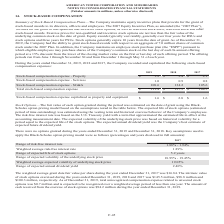According to American Tower Corporation's financial document, What was the Stock-based compensation expense - Property in 2019? According to the financial document, $1.8 (in millions). The relevant text states: "Stock-based compensation expense - Property $ 1.8 $ 2.4 $ 2.1 Stock-based compensation expense - Services 1.0 0.9 0.8..." Also, Which years did the company record and capitalize stock-based compensation expenses? The document contains multiple relevant values: 2019, 2018, 2017. From the document: "2019 2018 2017 2019 2018 2017 2019 2018 2017..." Also, What was the Total stock-based compensation expense in 2017? According to the financial document, $108.5 (in millions). The relevant text states: "tock-based compensation expense $ 111.4 $ 137.5 $ 108.5..." Also, How many years did Total stock-based compensation expense exceed $100 million? Counting the relevant items in the document: 2019, 2018, 2017, I find 3 instances. The key data points involved are: 2017, 2018, 2019. Also, How many years did Stock-based compensation expense - Services exceed $1 million? Based on the analysis, there are 1 instances. The counting process: 2019. Also, can you calculate: What was the percentage change in Total stock-based compensation expense between 2018 and 2019? To answer this question, I need to perform calculations using the financial data. The calculation is: ($111.4-$137.5)/$137.5, which equals -18.98 (percentage). This is based on the information: "Total stock-based compensation expense $ 111.4 $ 137.5 $ 108.5 Total stock-based compensation expense $ 111.4 $ 137.5 $ 108.5..." The key data points involved are: 111.4, 137.5. 